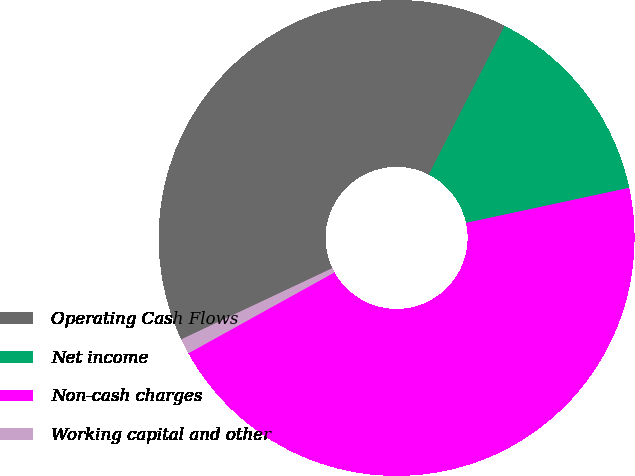Convert chart. <chart><loc_0><loc_0><loc_500><loc_500><pie_chart><fcel>Operating Cash Flows<fcel>Net income<fcel>Non-cash charges<fcel>Working capital and other<nl><fcel>39.52%<fcel>14.12%<fcel>45.32%<fcel>1.04%<nl></chart> 